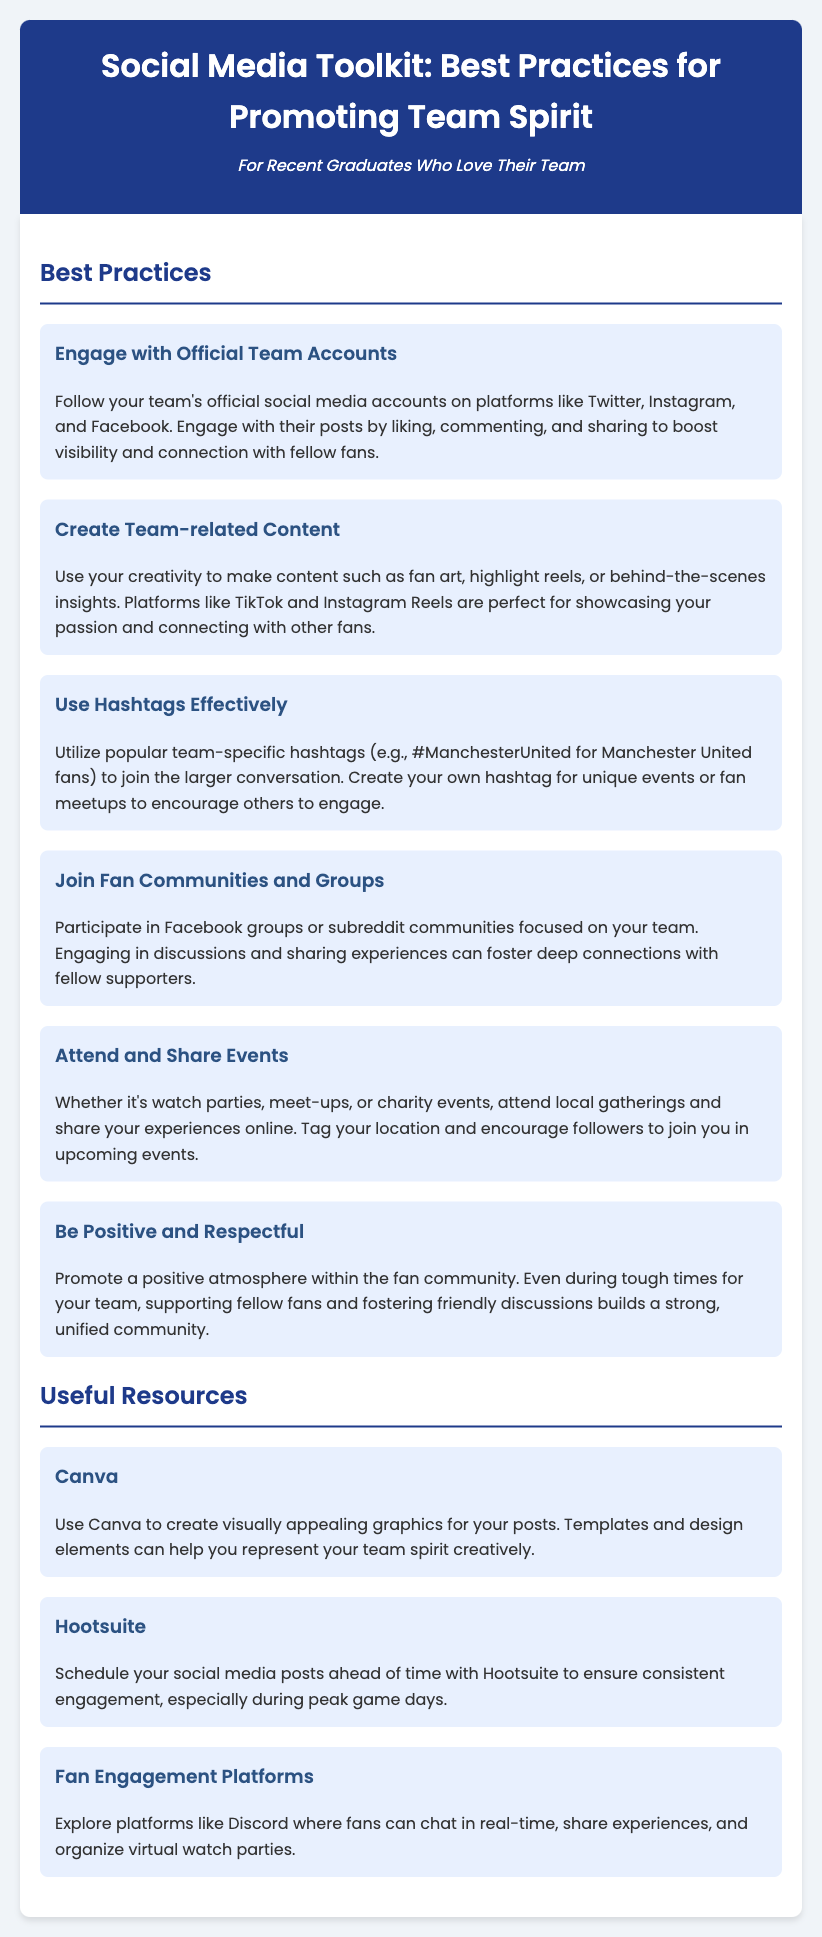What is the title of the document? The title is the main heading provided at the top of the document.
Answer: Social Media Toolkit: Best Practices for Promoting Team Spirit Who is the intended audience for this toolkit? The intended audience is specified in the introductory section of the document.
Answer: For Recent Graduates Who Love Their Team How many best practices are listed in the document? The number of best practices can be counted in the relevant section of the document.
Answer: Six What is one effective way to create team-related content? The document provides a suggestion for showcasing creativity with specific platform examples.
Answer: TikTok and Instagram Reels Which platform is recommended for scheduling social media posts? The document mentions a specific tool for post scheduling in the resources section.
Answer: Hootsuite What should you do during tough times for your team? The document advises on behavior during challenging periods for maintaining community spirit.
Answer: Promote a positive atmosphere Which tool can help you create graphics for posts? A specific resource is mentioned for creating visually appealing content in the document.
Answer: Canva What is encouraged when attending local team events? The document suggests a specific action to take when sharing experiences from events.
Answer: Tag your location 